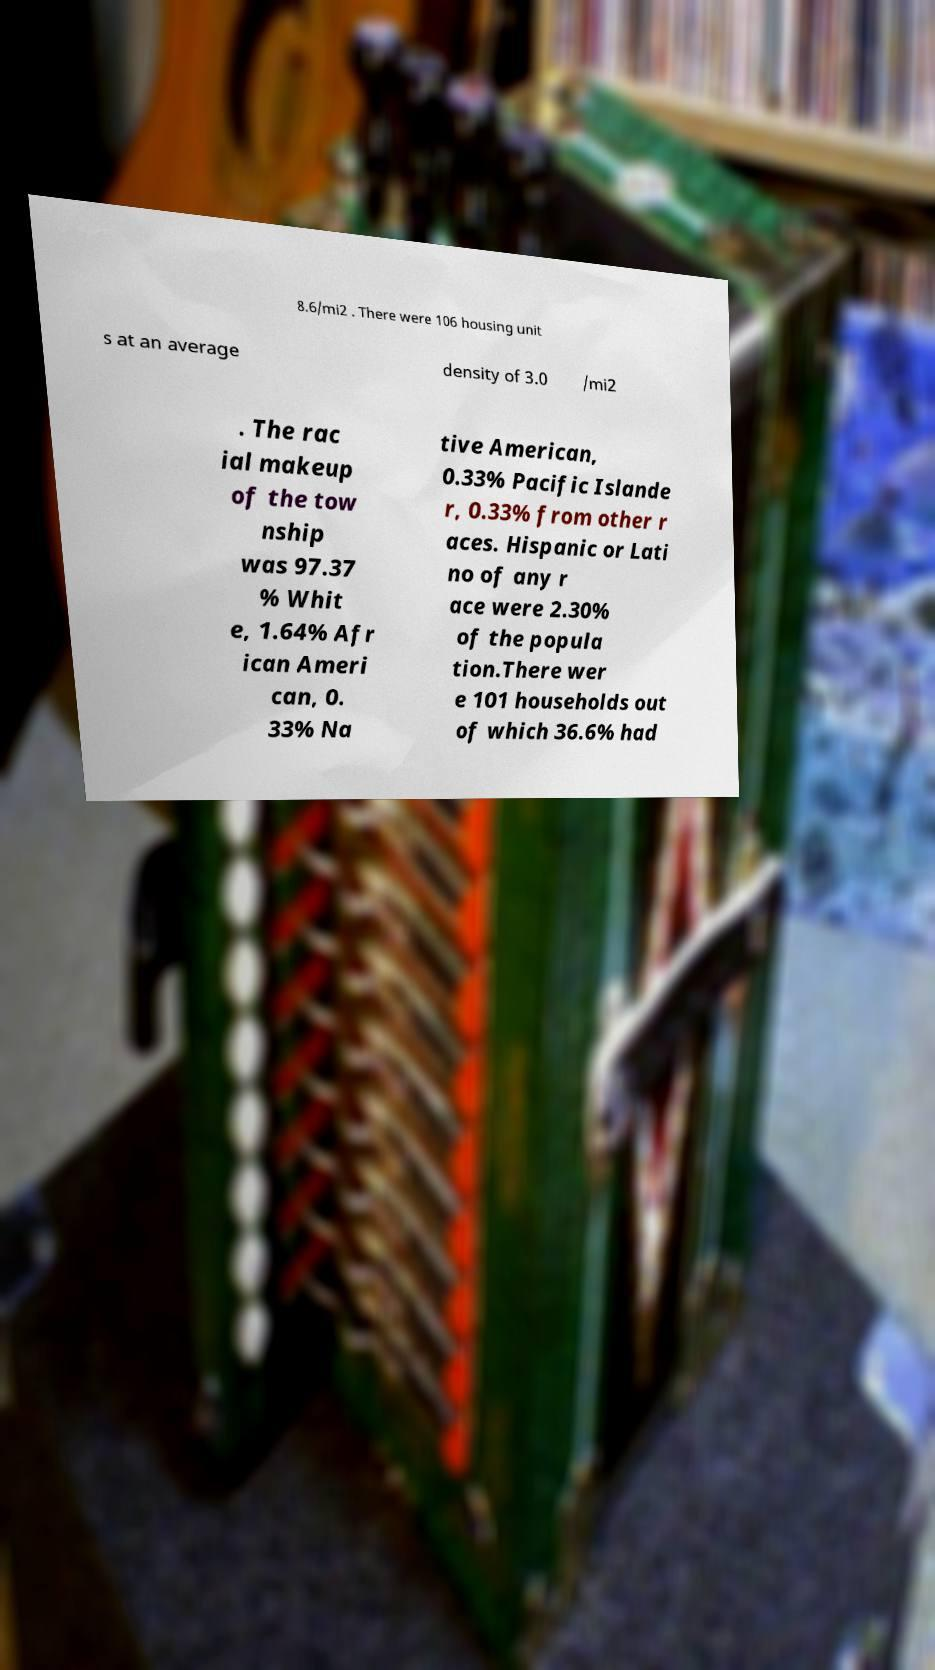What messages or text are displayed in this image? I need them in a readable, typed format. 8.6/mi2 . There were 106 housing unit s at an average density of 3.0 /mi2 . The rac ial makeup of the tow nship was 97.37 % Whit e, 1.64% Afr ican Ameri can, 0. 33% Na tive American, 0.33% Pacific Islande r, 0.33% from other r aces. Hispanic or Lati no of any r ace were 2.30% of the popula tion.There wer e 101 households out of which 36.6% had 